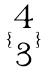<formula> <loc_0><loc_0><loc_500><loc_500>\{ \begin{matrix} 4 \\ 3 \end{matrix} \}</formula> 